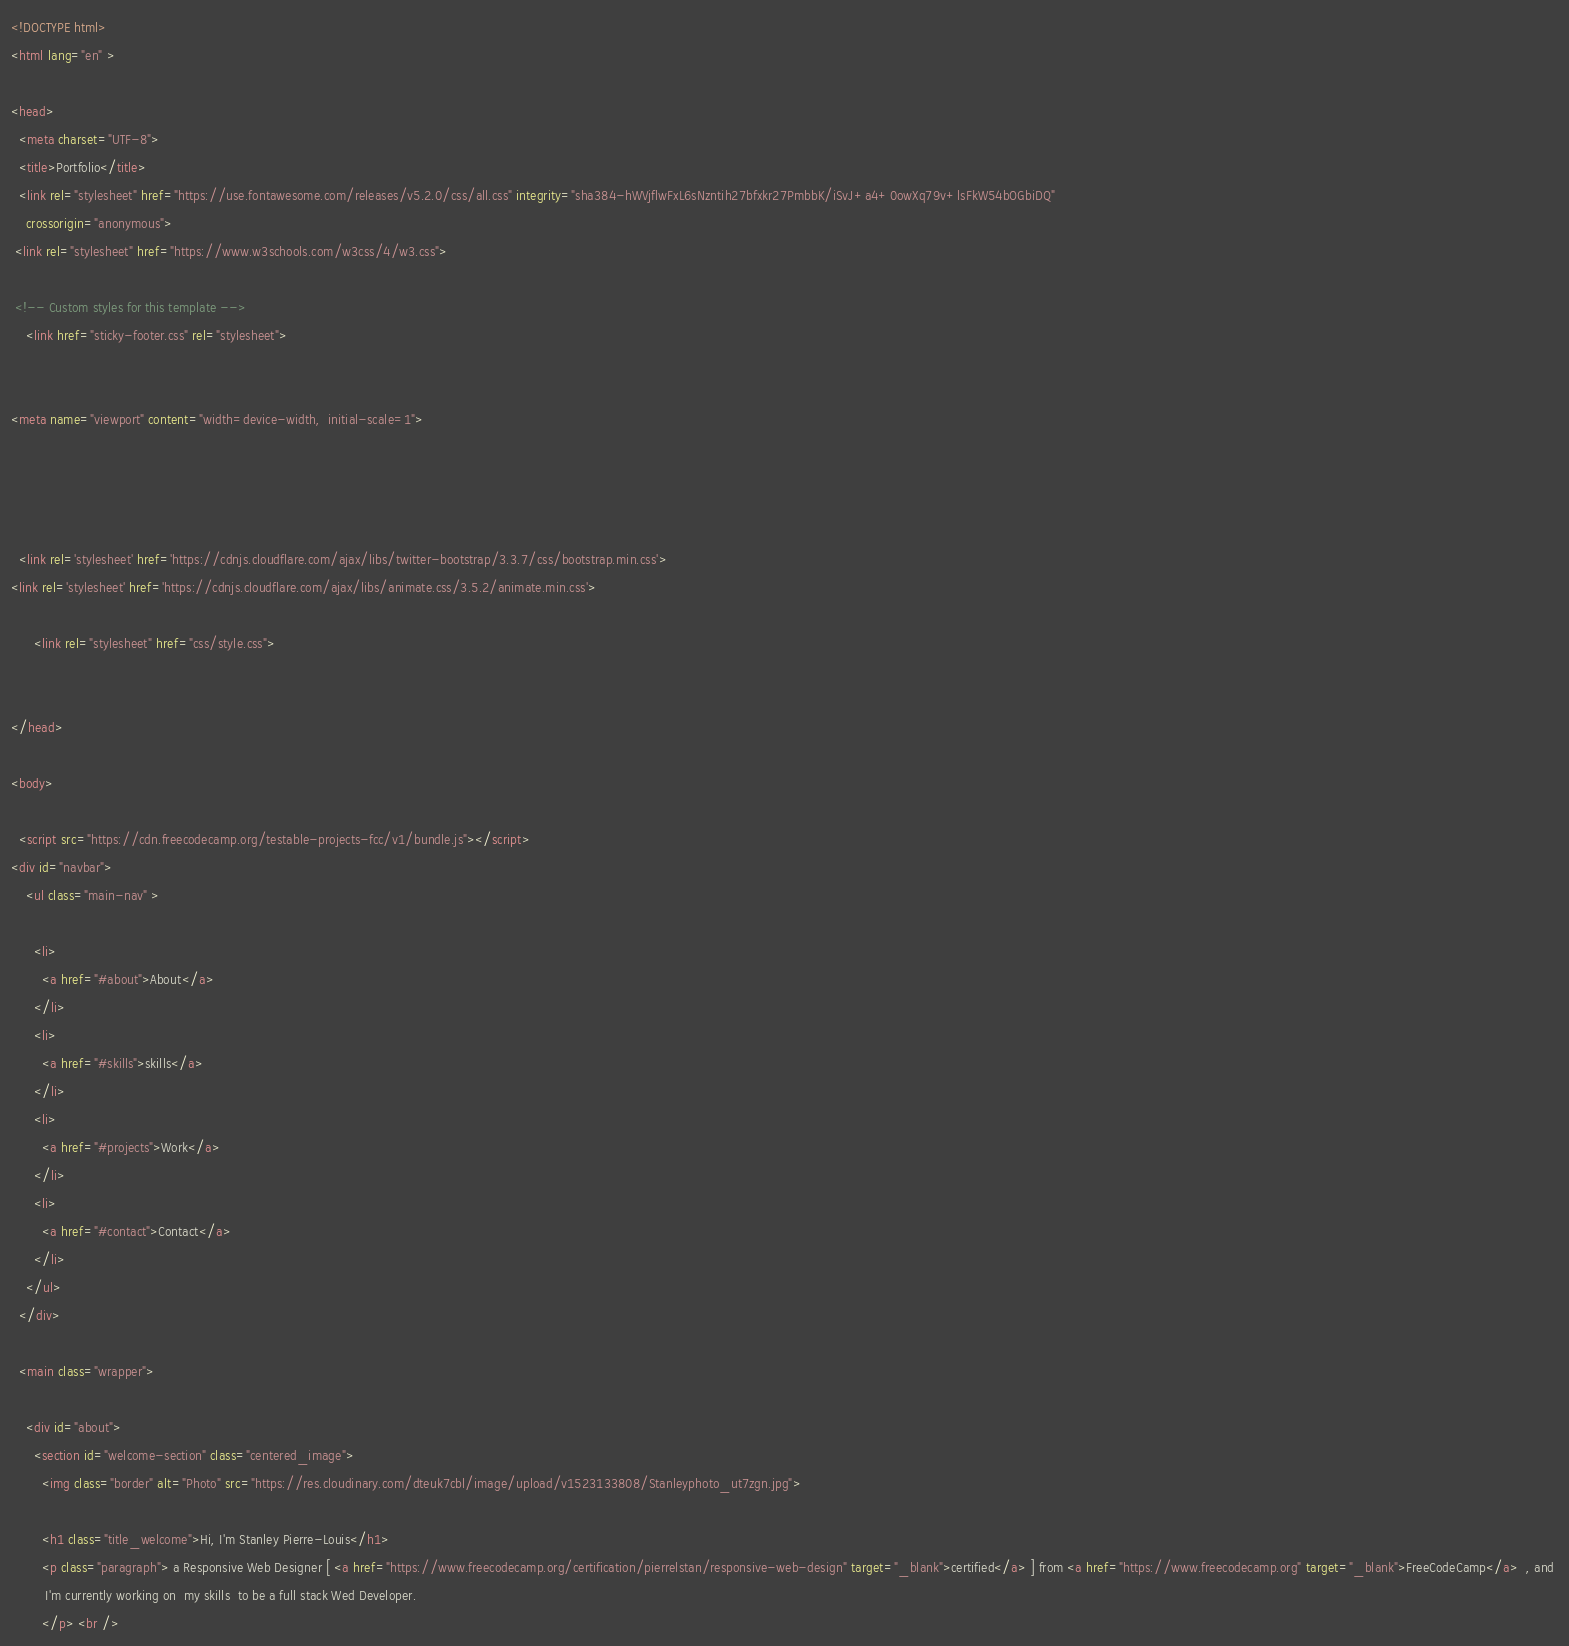Convert code to text. <code><loc_0><loc_0><loc_500><loc_500><_HTML_><!DOCTYPE html>
<html lang="en" >

<head>
  <meta charset="UTF-8">
  <title>Portfolio</title>
  <link rel="stylesheet" href="https://use.fontawesome.com/releases/v5.2.0/css/all.css" integrity="sha384-hWVjflwFxL6sNzntih27bfxkr27PmbbK/iSvJ+a4+0owXq79v+lsFkW54bOGbiDQ"
    crossorigin="anonymous">
 <link rel="stylesheet" href="https://www.w3schools.com/w3css/4/w3.css">

 <!-- Custom styles for this template -->
    <link href="sticky-footer.css" rel="stylesheet">


<meta name="viewport" content="width=device-width,  initial-scale=1">



  
  <link rel='stylesheet' href='https://cdnjs.cloudflare.com/ajax/libs/twitter-bootstrap/3.3.7/css/bootstrap.min.css'>
<link rel='stylesheet' href='https://cdnjs.cloudflare.com/ajax/libs/animate.css/3.5.2/animate.min.css'>

      <link rel="stylesheet" href="css/style.css">

  
</head>

<body>

  <script src="https://cdn.freecodecamp.org/testable-projects-fcc/v1/bundle.js"></script> 
<div id="navbar">
    <ul class="main-nav" >

      <li>
        <a href="#about">About</a>
      </li>
      <li>
        <a href="#skills">skills</a>
      </li>
      <li>
        <a href="#projects">Work</a>
      </li>
      <li>
        <a href="#contact">Contact</a>
      </li>
    </ul>
  </div>
  
  <main class="wrapper">

    <div id="about">
      <section id="welcome-section" class="centered_image">
        <img class="border" alt="Photo" src="https://res.cloudinary.com/dteuk7cbl/image/upload/v1523133808/Stanleyphoto_ut7zgn.jpg">

        <h1 class="title_welcome">Hi, I'm Stanley Pierre-Louis</h1>
        <p class="paragraph"> a Responsive Web Designer [ <a href="https://www.freecodecamp.org/certification/pierrelstan/responsive-web-design" target="_blank">certified</a> ] from <a href="https://www.freecodecamp.org" target="_blank">FreeCodeCamp</a>  , and 
         I'm currently working on  my skills  to be a full stack Wed Developer.
        </p> <br /></code> 